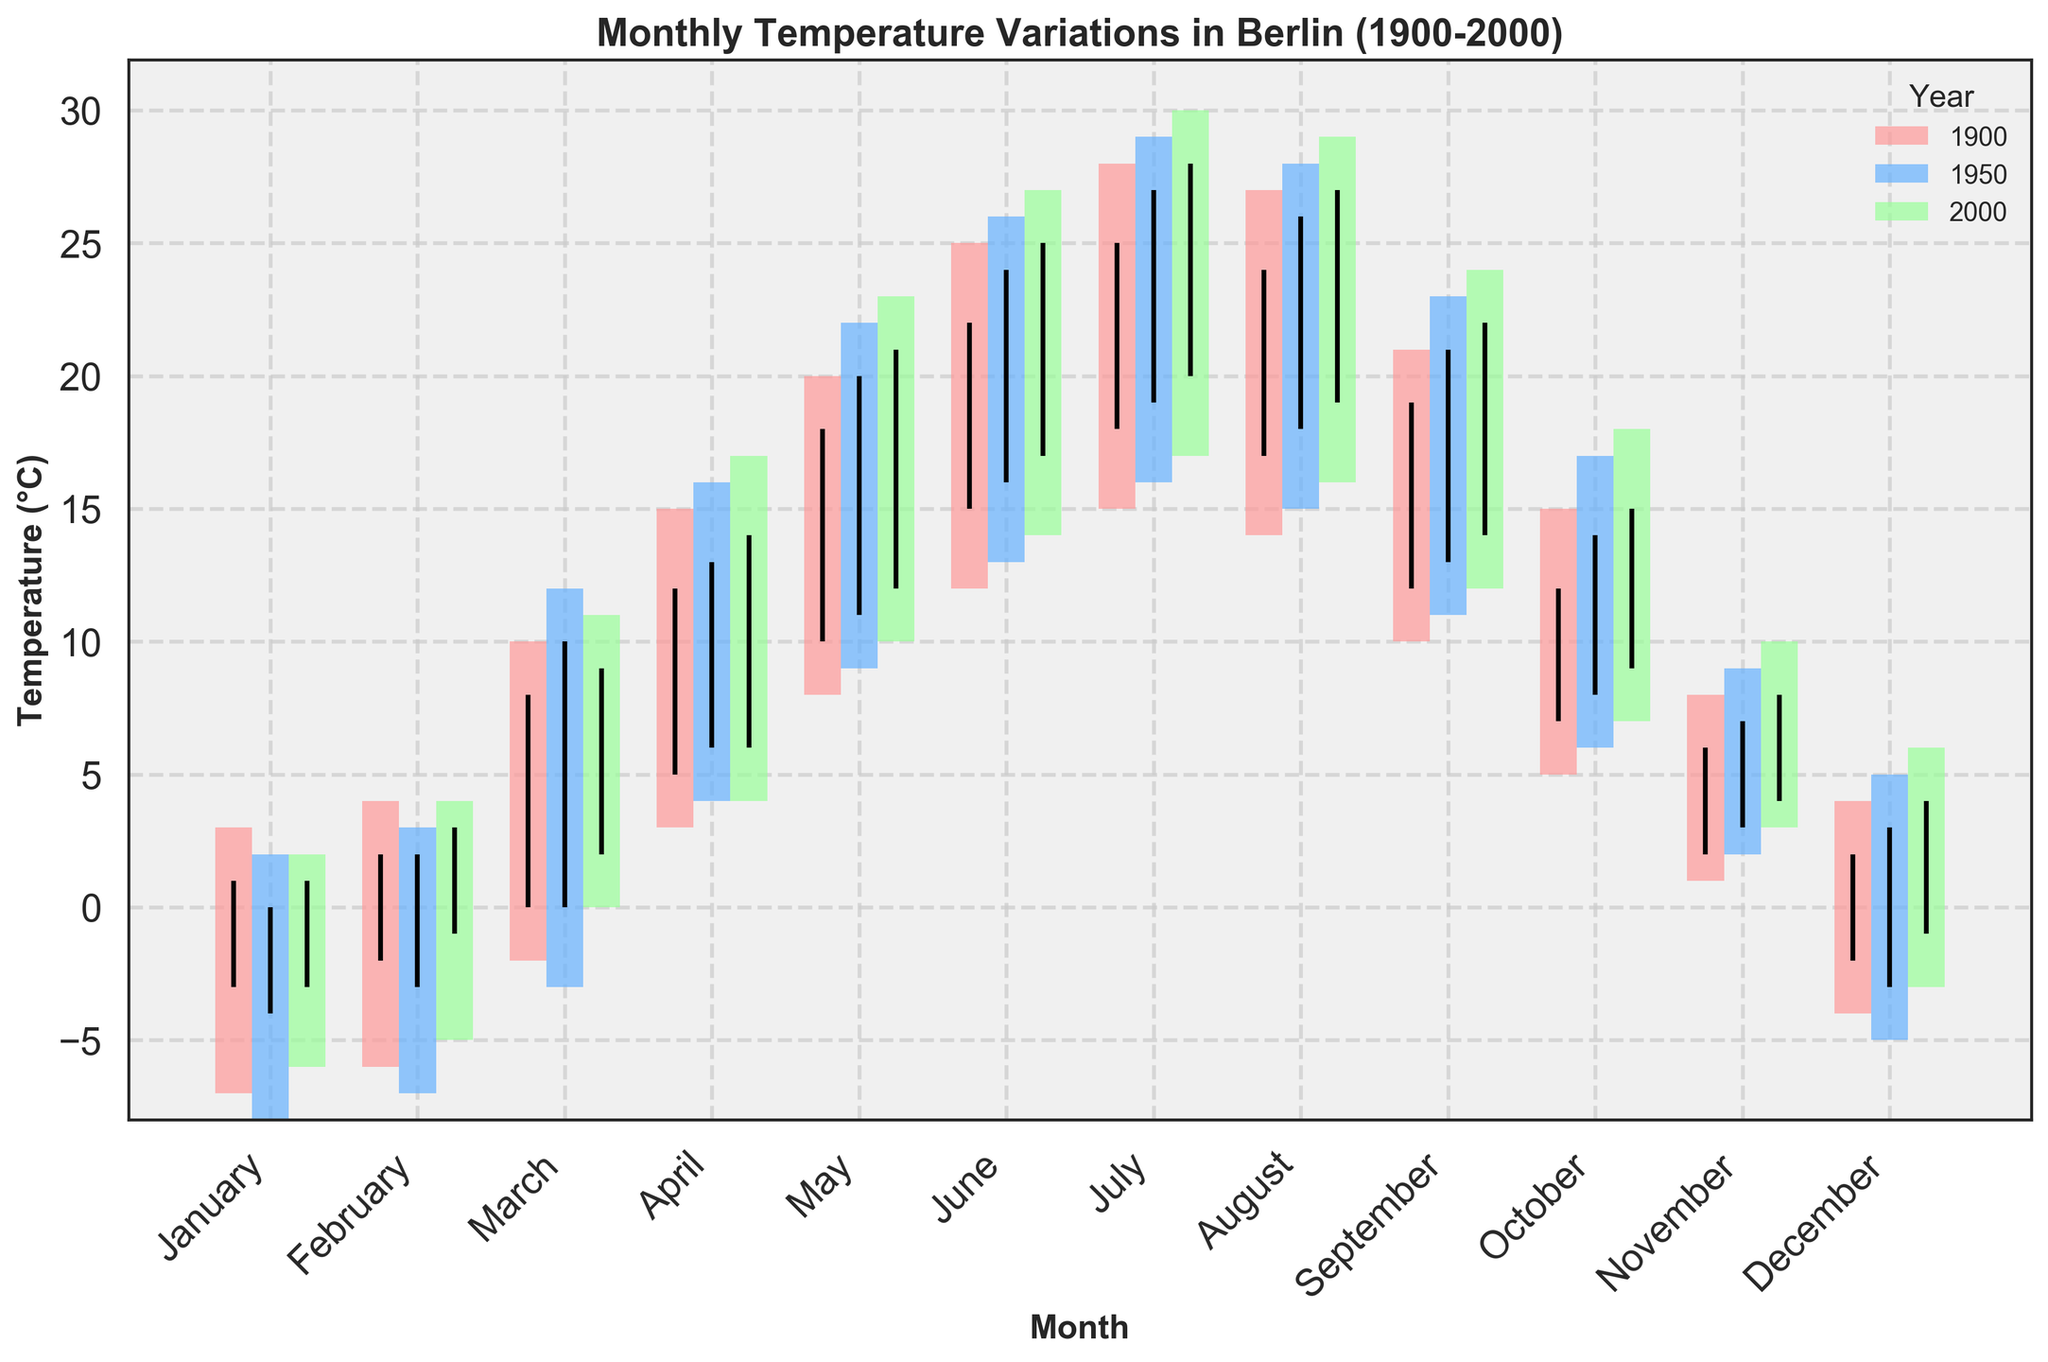What are the years displayed in the plot? The years are indicated by different colors in the legend. By looking at the legend, we can identify the years represented in the plot.
Answer: 1900, 1950, 2000 What is the highest temperature recorded in July 2000? To find the highest temperature for July 2000, look for the bar corresponding to July and the year 2000 (identified by its unique color in the legend). The top end of the bar represents the high temperature.
Answer: 30°C How does the temperature variation in January 1950 compare to January 1900? To compare January 1950 and January 1900, find the bars for January and examine their lengths. The length represents the temperature range (High - Low). Compare both temperature ranges.
Answer: January 1950 has a higher variation (10°C) than January 1900 (10°C) Which month shows the smallest temperature range in 2000? Look at the width of each bar in the 2000 color. The smallest bar indicates the smallest temperature range (High - Low). Compare all the bars for 2000.
Answer: January and February (10°C) What is the overall trend of the closing temperatures from January to December for the years displayed? To determine the trend in closing temperatures, examine the positions of the black dashes (representing the closing temperatures) from January to December for each year. Note whether they generally increase, decrease or remain stable.
Answer: Generally increase from January to July/August, then decrease to December In which year did July have the highest closing temperature? To find the highest closing temperature in July, compare the positions of the black dashes for July for each year. The highest closing temperature is the highest black dash.
Answer: 2000 (28°C) How does the average temperature range (High - Low) for November differ between 1900 and 2000? Calculate the average temperature range by subtracting the low from the high for each November and take the average of these ranges for 1900 and 2000, respectively. Compare these averages.
Answer: 1900 (7°C), 2000 (7°C) - No difference Which year's August experienced the lowest low temperature, and what was it? Compare the bottom endpoints of the bars for August across all years. The bar with the lowest bottom end represents the lowest low temperature.
Answer: 15°C (1950) What was the temperature range in October 1950? The temperature range is the difference between the high and low temperatures. Find the bar for October 1950 and use the top and bottom of the bar to find the range.
Answer: 11°C (17 - 6) Is there any month where all three years had nearly the same temperature range? Compare the lengths of the bars (Temperature range) for each month across all three years. Identify any month where the bars are approximately the same length.
Answer: August 